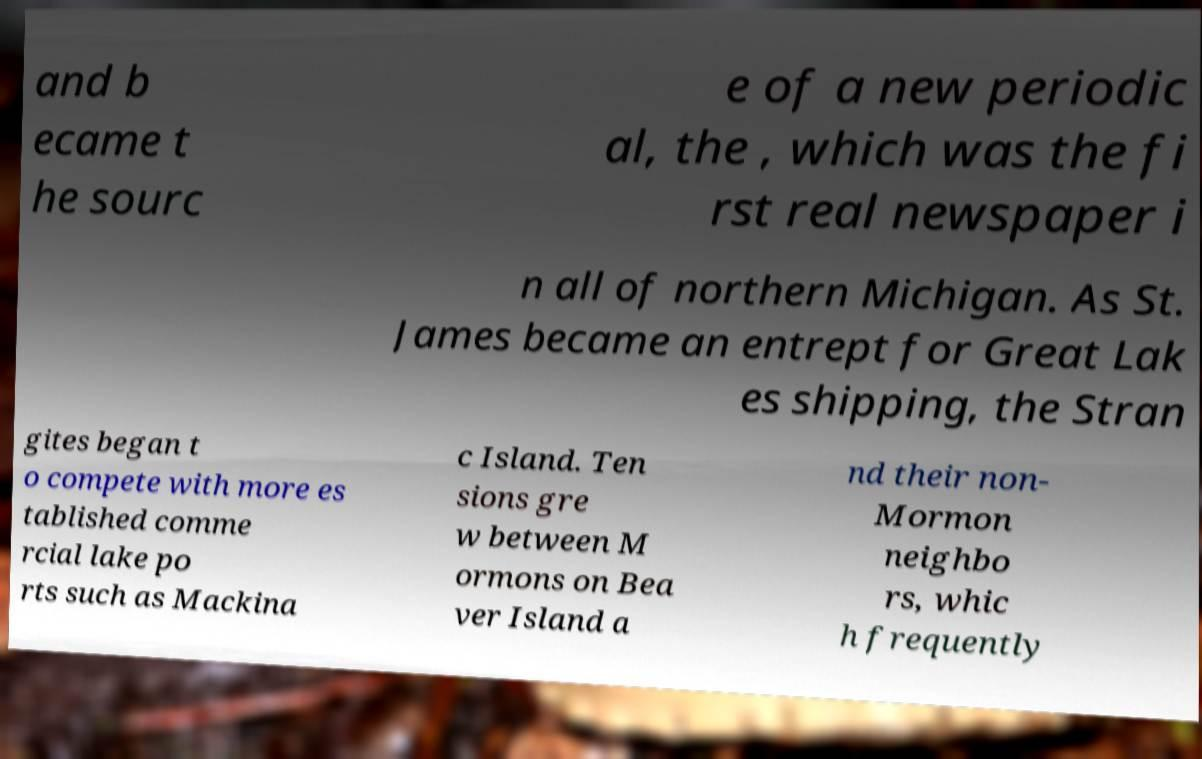Please read and relay the text visible in this image. What does it say? and b ecame t he sourc e of a new periodic al, the , which was the fi rst real newspaper i n all of northern Michigan. As St. James became an entrept for Great Lak es shipping, the Stran gites began t o compete with more es tablished comme rcial lake po rts such as Mackina c Island. Ten sions gre w between M ormons on Bea ver Island a nd their non- Mormon neighbo rs, whic h frequently 